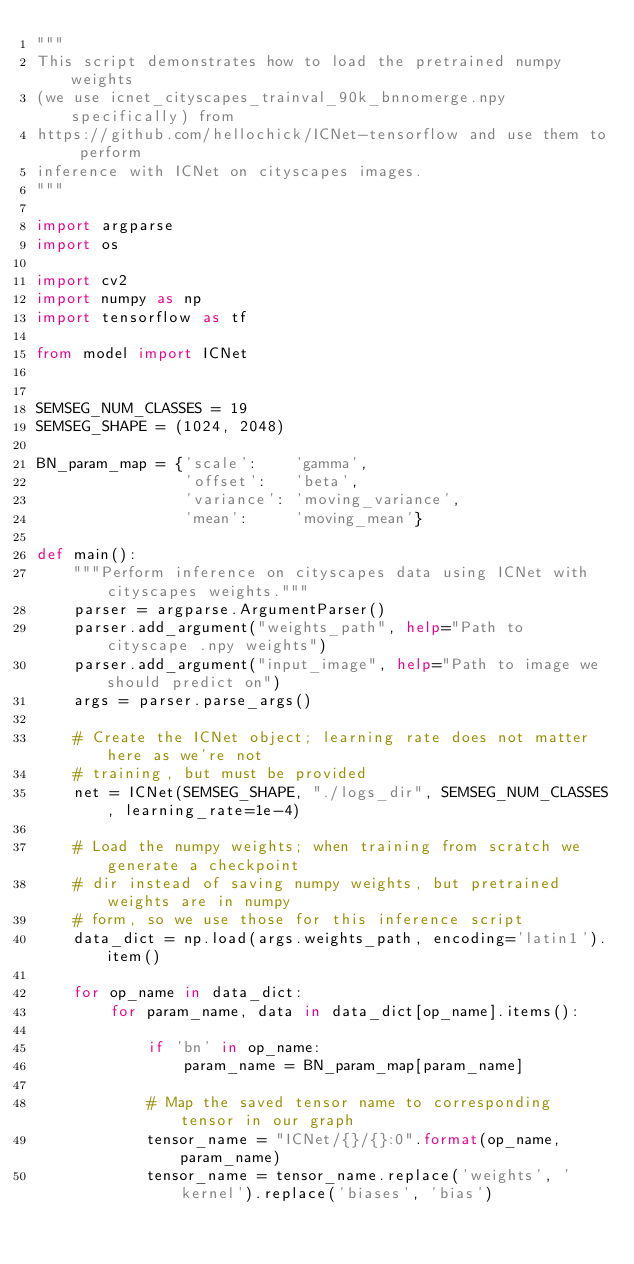<code> <loc_0><loc_0><loc_500><loc_500><_Python_>"""
This script demonstrates how to load the pretrained numpy weights
(we use icnet_cityscapes_trainval_90k_bnnomerge.npy specifically) from
https://github.com/hellochick/ICNet-tensorflow and use them to perform
inference with ICNet on cityscapes images.
"""

import argparse
import os

import cv2
import numpy as np
import tensorflow as tf

from model import ICNet


SEMSEG_NUM_CLASSES = 19
SEMSEG_SHAPE = (1024, 2048)

BN_param_map = {'scale':    'gamma',
                'offset':   'beta',
                'variance': 'moving_variance',
                'mean':     'moving_mean'}

def main():
    """Perform inference on cityscapes data using ICNet with cityscapes weights."""
    parser = argparse.ArgumentParser()
    parser.add_argument("weights_path", help="Path to cityscape .npy weights")
    parser.add_argument("input_image", help="Path to image we should predict on")
    args = parser.parse_args()

    # Create the ICNet object; learning rate does not matter here as we're not
    # training, but must be provided
    net = ICNet(SEMSEG_SHAPE, "./logs_dir", SEMSEG_NUM_CLASSES, learning_rate=1e-4)

    # Load the numpy weights; when training from scratch we generate a checkpoint
    # dir instead of saving numpy weights, but pretrained weights are in numpy
    # form, so we use those for this inference script
    data_dict = np.load(args.weights_path, encoding='latin1').item()

    for op_name in data_dict:
        for param_name, data in data_dict[op_name].items():

            if 'bn' in op_name:
                param_name = BN_param_map[param_name]

            # Map the saved tensor name to corresponding tensor in our graph
            tensor_name = "ICNet/{}/{}:0".format(op_name, param_name)
            tensor_name = tensor_name.replace('weights', 'kernel').replace('biases', 'bias')</code> 